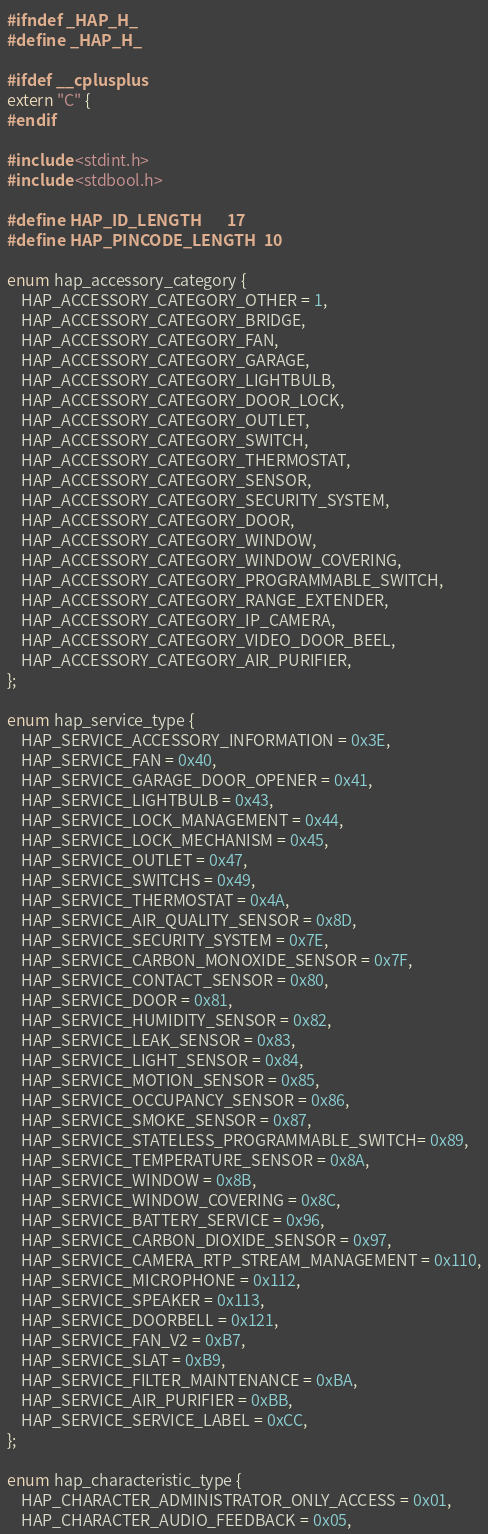<code> <loc_0><loc_0><loc_500><loc_500><_C_>#ifndef _HAP_H_
#define _HAP_H_

#ifdef __cplusplus
extern "C" {
#endif

#include <stdint.h>
#include <stdbool.h>

#define HAP_ID_LENGTH       17
#define HAP_PINCODE_LENGTH  10

enum hap_accessory_category {
    HAP_ACCESSORY_CATEGORY_OTHER = 1,
    HAP_ACCESSORY_CATEGORY_BRIDGE,
    HAP_ACCESSORY_CATEGORY_FAN,
    HAP_ACCESSORY_CATEGORY_GARAGE,
    HAP_ACCESSORY_CATEGORY_LIGHTBULB,
    HAP_ACCESSORY_CATEGORY_DOOR_LOCK,
    HAP_ACCESSORY_CATEGORY_OUTLET,
    HAP_ACCESSORY_CATEGORY_SWITCH,
    HAP_ACCESSORY_CATEGORY_THERMOSTAT,
    HAP_ACCESSORY_CATEGORY_SENSOR,
    HAP_ACCESSORY_CATEGORY_SECURITY_SYSTEM,
    HAP_ACCESSORY_CATEGORY_DOOR,
    HAP_ACCESSORY_CATEGORY_WINDOW,
    HAP_ACCESSORY_CATEGORY_WINDOW_COVERING,
    HAP_ACCESSORY_CATEGORY_PROGRAMMABLE_SWITCH,
    HAP_ACCESSORY_CATEGORY_RANGE_EXTENDER,
    HAP_ACCESSORY_CATEGORY_IP_CAMERA,
    HAP_ACCESSORY_CATEGORY_VIDEO_DOOR_BEEL,
    HAP_ACCESSORY_CATEGORY_AIR_PURIFIER,
};

enum hap_service_type {
    HAP_SERVICE_ACCESSORY_INFORMATION = 0x3E,
    HAP_SERVICE_FAN = 0x40,
    HAP_SERVICE_GARAGE_DOOR_OPENER = 0x41,
    HAP_SERVICE_LIGHTBULB = 0x43,
    HAP_SERVICE_LOCK_MANAGEMENT = 0x44,
    HAP_SERVICE_LOCK_MECHANISM = 0x45,
    HAP_SERVICE_OUTLET = 0x47,
    HAP_SERVICE_SWITCHS = 0x49,
    HAP_SERVICE_THERMOSTAT = 0x4A,
    HAP_SERVICE_AIR_QUALITY_SENSOR = 0x8D,
    HAP_SERVICE_SECURITY_SYSTEM = 0x7E,
    HAP_SERVICE_CARBON_MONOXIDE_SENSOR = 0x7F,
    HAP_SERVICE_CONTACT_SENSOR = 0x80,
    HAP_SERVICE_DOOR = 0x81,
    HAP_SERVICE_HUMIDITY_SENSOR = 0x82,
    HAP_SERVICE_LEAK_SENSOR = 0x83,
    HAP_SERVICE_LIGHT_SENSOR = 0x84,
    HAP_SERVICE_MOTION_SENSOR = 0x85,
    HAP_SERVICE_OCCUPANCY_SENSOR = 0x86,
    HAP_SERVICE_SMOKE_SENSOR = 0x87,
    HAP_SERVICE_STATELESS_PROGRAMMABLE_SWITCH= 0x89,
    HAP_SERVICE_TEMPERATURE_SENSOR = 0x8A,
    HAP_SERVICE_WINDOW = 0x8B,
    HAP_SERVICE_WINDOW_COVERING = 0x8C,
    HAP_SERVICE_BATTERY_SERVICE = 0x96,
    HAP_SERVICE_CARBON_DIOXIDE_SENSOR = 0x97,
    HAP_SERVICE_CAMERA_RTP_STREAM_MANAGEMENT = 0x110,
    HAP_SERVICE_MICROPHONE = 0x112,
    HAP_SERVICE_SPEAKER = 0x113,
    HAP_SERVICE_DOORBELL = 0x121,
    HAP_SERVICE_FAN_V2 = 0xB7,
    HAP_SERVICE_SLAT = 0xB9,
    HAP_SERVICE_FILTER_MAINTENANCE = 0xBA,
    HAP_SERVICE_AIR_PURIFIER = 0xBB,
    HAP_SERVICE_SERVICE_LABEL = 0xCC,
};

enum hap_characteristic_type {
    HAP_CHARACTER_ADMINISTRATOR_ONLY_ACCESS = 0x01,
    HAP_CHARACTER_AUDIO_FEEDBACK = 0x05,</code> 